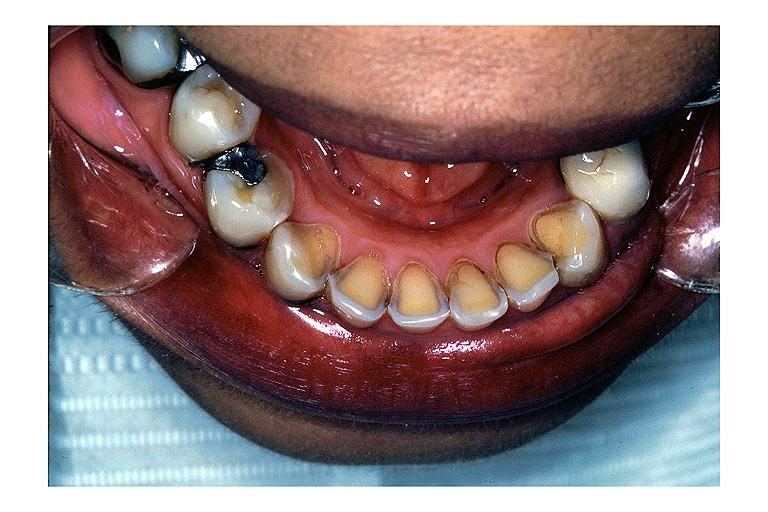s cortical nodule present?
Answer the question using a single word or phrase. No 